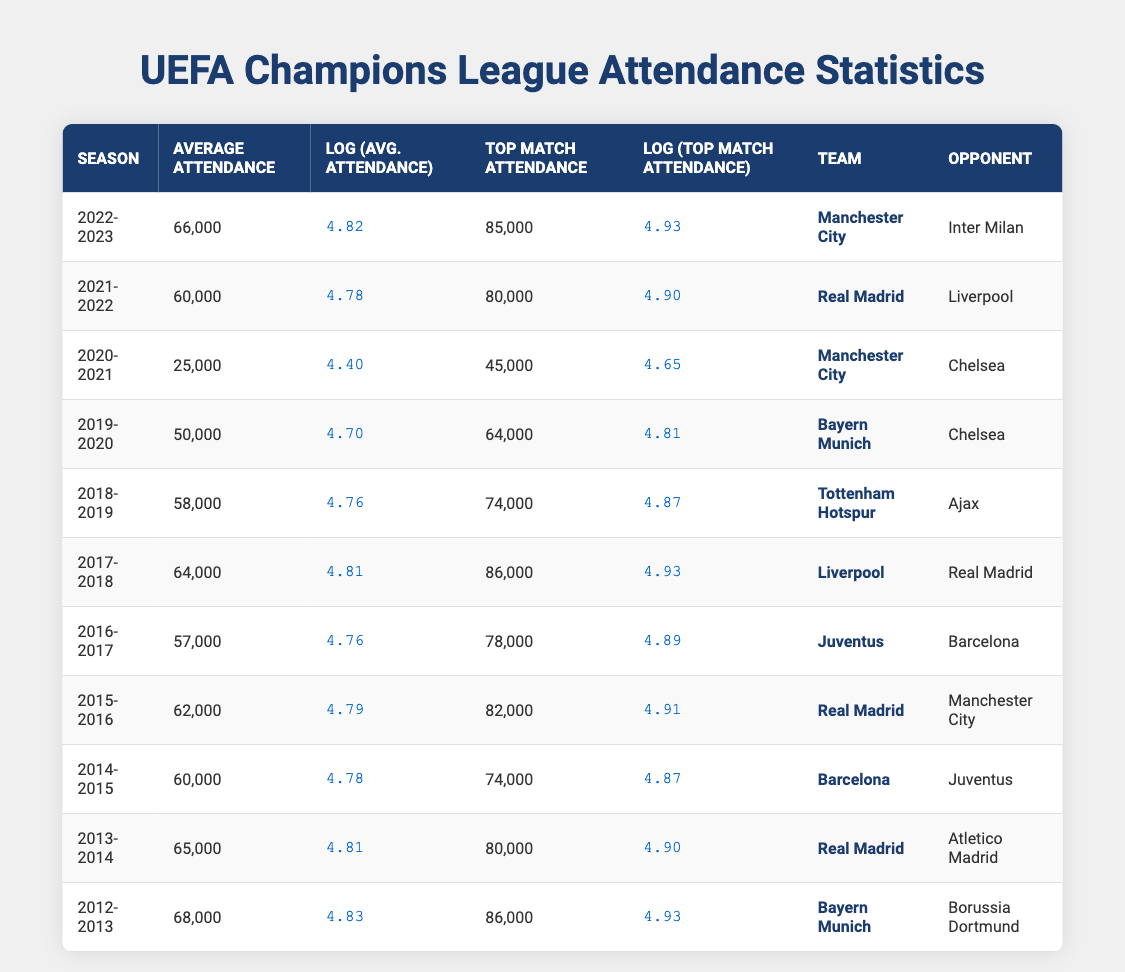What was the highest average attendance recorded in the past decade? The data shows the average attendance for each season. By looking through the average attendance values, I see that the highest value is 68,000 in the 2012-2013 season.
Answer: 68,000 Which season had the lowest top match attendance? By checking the top match attendance column, I find that the lowest value is 45,000, which occurred in the 2020-2021 season.
Answer: 2020-2021 What is the difference between the top match attendance in the 2022-2023 season and the 2019-2020 season? The top match attendance for 2022-2023 is 85,000, and for 2019-2020, it is 64,000. The difference is 85,000 - 64,000 = 21,000.
Answer: 21,000 Did Real Madrid ever have an average attendance lower than 60,000? By examining the table, I see that Real Madrid's average attendance was 60,000 in the 2021-2022 season, and in 2020-2021 it dropped to 25,000. Therefore, the statement is true.
Answer: Yes What was the average attendance for the seasons where Juventus appeared? Juventus appeared in the seasons 2016-2017 (57,000), 2017-2018 (64,000), and 2014-2015 (60,000). The average attendance is (57,000 + 64,000 + 60,000) / 3 = 180,000 / 3 = 60,000.
Answer: 60,000 Which team had the top match attendance in the 2015-2016 season? In the 2015-2016 season, the team listed is Real Madrid, with a top match attendance of 82,000.
Answer: Real Madrid What is the average top match attendance over the last decade? To calculate the average top match attendance from the data, I need to sum all top match attendances (86,000 + 80,000 + 74,000 + 82,000 + 78,000 + 86,000 + 74,000 + 64,000 + 45,000 + 80,000 + 86,000) and then divide by 11, the number of seasons. The total attendance is 1,024,000, so the average is 1,024,000 / 11 ≈ 93,090.91 rounded down to 93,090.
Answer: 93,090 Was the average attendance in 2020-2021 higher than that in 2019-2020? For 2020-2021, the average attendance was 25,000, while in 2019-2020 it was 50,000. Since 25,000 is less than 50,000, the statement is false.
Answer: No In which season did Manchester City have the highest average attendance? Manchester City had an average attendance of 66,000 in the 2022-2023 season. Looking at previous seasons, the next highest is 25,000 in 2020-2021. Therefore, 66,000 is the highest for Manchester City.
Answer: 2022-2023 